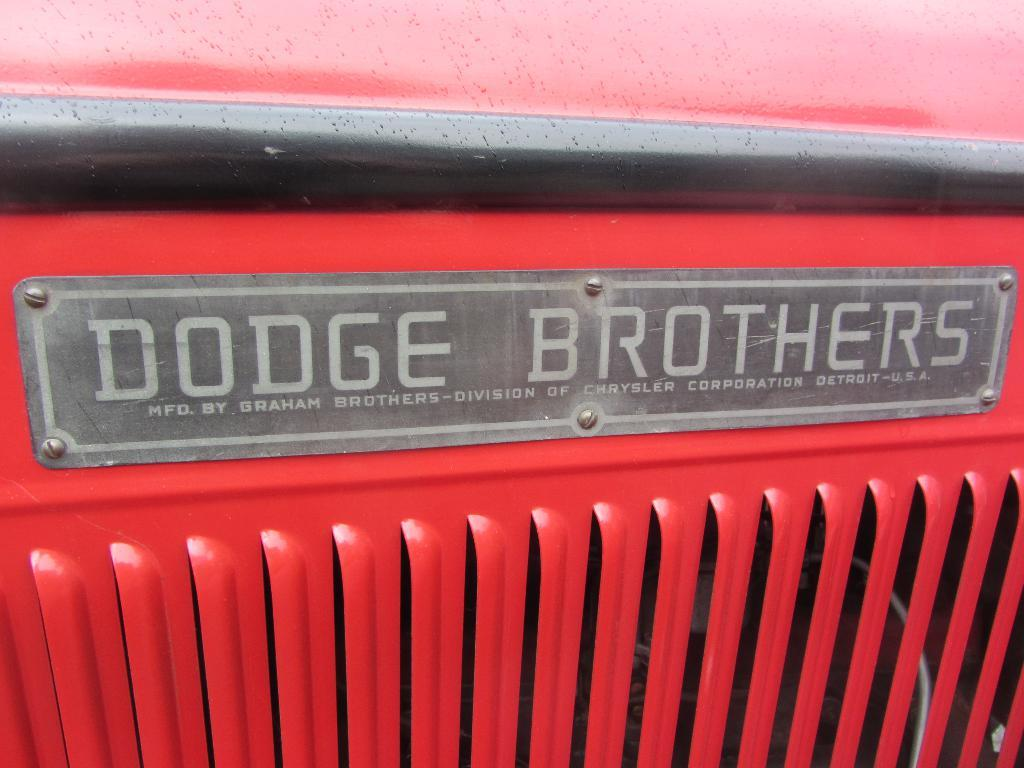What is the main subject of the image? There is a vehicle in the image. What color is the vehicle? The vehicle is red in color. What else can be seen in the image besides the vehicle? There is a board in the image. What is written or depicted on the board? There is text on the board. How does the vehicle cry in the image? Vehicles do not have the ability to cry, so this action cannot be observed in the image. 